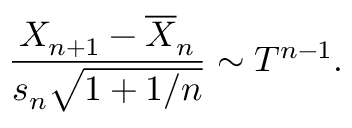<formula> <loc_0><loc_0><loc_500><loc_500>{ \frac { X _ { n + 1 } - { \overline { X } } _ { n } } { s _ { n } { \sqrt { 1 + 1 / n } } } } \sim T ^ { n - 1 } .</formula> 